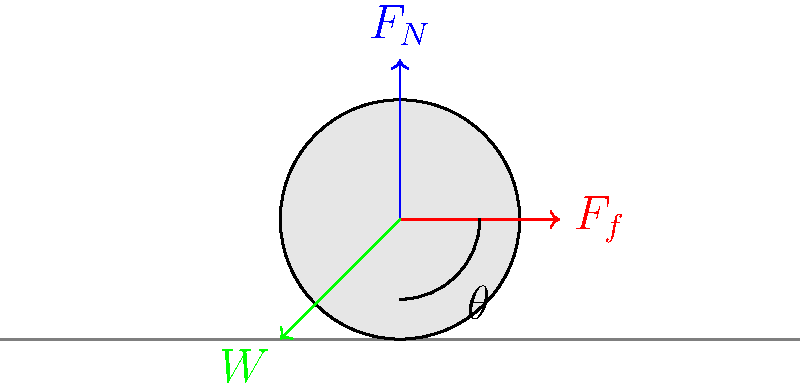A robotic vacuum cleaner is moving across a flat surface. If the coefficient of friction between the cleaner and the floor is $\mu = 0.2$, and the angle $\theta$ between the floor and the direction of motion is $30°$, what is the minimum mass of the vacuum cleaner required to prevent it from sliding down the incline? To solve this problem, we need to follow these steps:

1) First, let's identify the forces acting on the vacuum cleaner:
   - Weight (W): acts downward
   - Normal force (F_N): perpendicular to the surface
   - Friction force (F_f): parallel to the surface, opposing motion

2) For the vacuum cleaner to not slide down, the friction force must be equal to or greater than the component of weight parallel to the surface:

   $F_f \geq W \sin \theta$

3) We know that friction force is related to the normal force by the coefficient of friction:

   $F_f = \mu F_N$

4) The normal force is related to the weight and the angle:

   $F_N = W \cos \theta$

5) Substituting these into our inequality:

   $\mu W \cos \theta \geq W \sin \theta$

6) Simplifying:

   $\mu \cos \theta \geq \sin \theta$
   $\mu \geq \tan \theta$

7) We're given $\mu = 0.2$ and $\theta = 30°$. Let's check if this inequality holds:

   $0.2 \geq \tan 30° \approx 0.577$

8) Since this inequality doesn't hold, the vacuum cleaner will slide unless additional weight is added.

9) To find the minimum mass, we need to solve:

   $\mu = \tan \theta$
   $0.2 m g \cos 30° = m g \sin 30°$

10) The mass (m) and acceleration due to gravity (g) cancel out, leaving:

    $0.2 \cos 30° = \sin 30°$
    $0.2 * 0.866 = 0.5$
    $0.1732 = 0.5$

11) This equation doesn't balance, confirming that additional mass is needed. To find the required mass, we use:

    $F_f = \mu F_N = \mu m g \cos 30° = m g \sin 30°$

12) Solving for m:

    $m = \frac{g \sin 30°}{\mu g \cos 30°} = \frac{\sin 30°}{\mu \cos 30°} = \frac{0.5}{0.2 * 0.866} \approx 2.887$ kg
Answer: 2.887 kg 